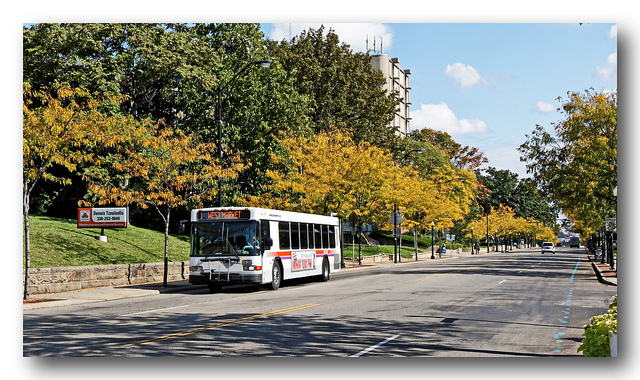Read all the text in this image. 2 1 